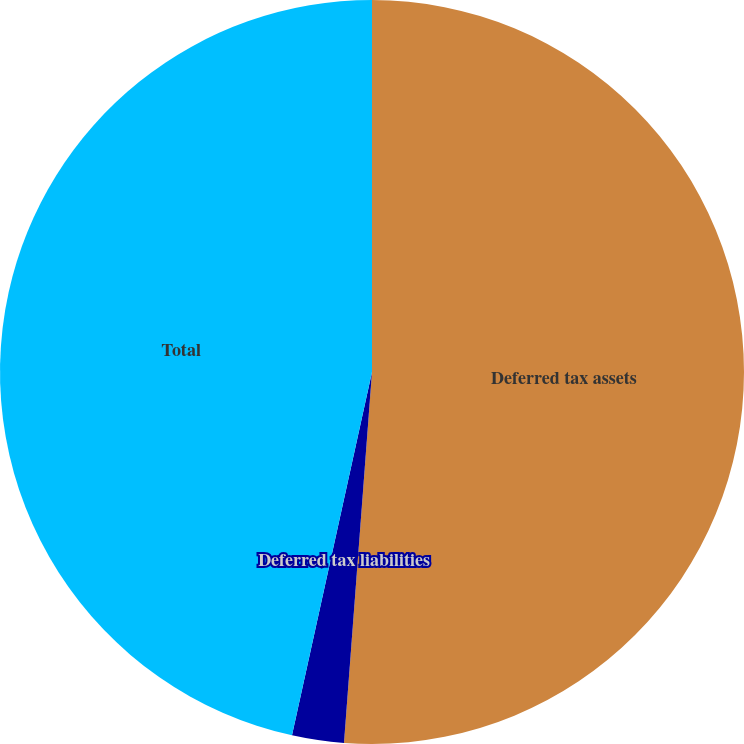Convert chart to OTSL. <chart><loc_0><loc_0><loc_500><loc_500><pie_chart><fcel>Deferred tax assets<fcel>Deferred tax liabilities<fcel>Total<nl><fcel>51.2%<fcel>2.25%<fcel>46.55%<nl></chart> 